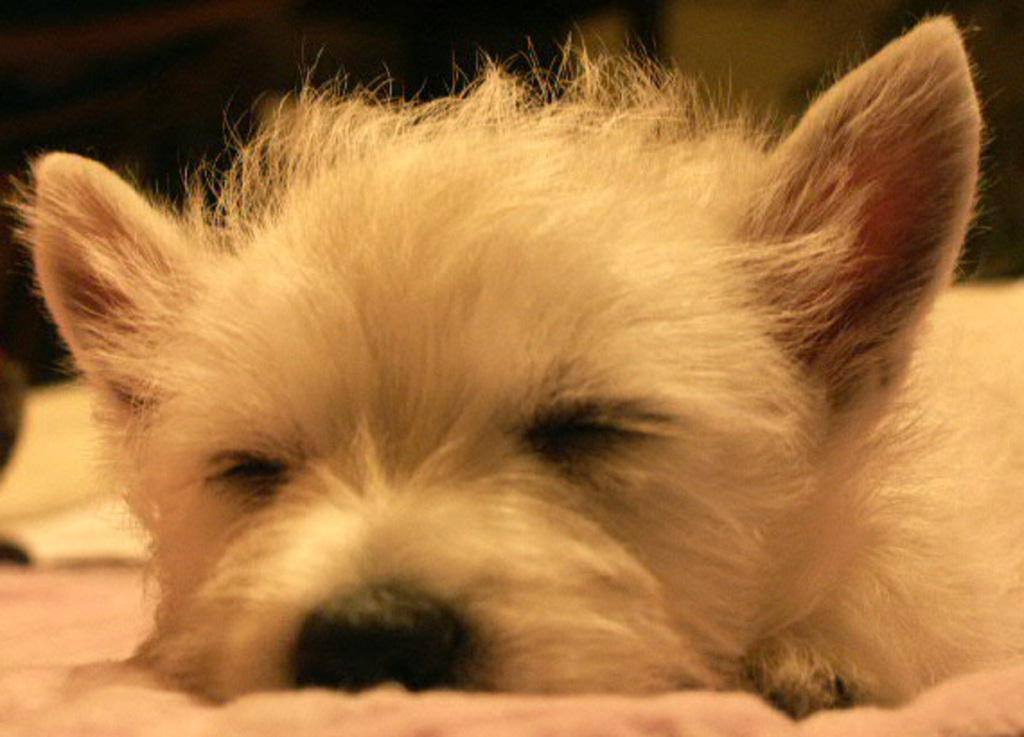What animal can be seen in the image? There is a dog in the image. What is the dog doing in the image? The dog is sleeping. What other object is present in the image? There is a book in the image. What can be observed about the background of the image? The background of the image is dark. How many tomatoes are being digested by the dog in the image? There are no tomatoes present in the image, and the dog is not shown digesting anything. What type of station is visible in the background of the image? There is no station visible in the image; the background is dark. 